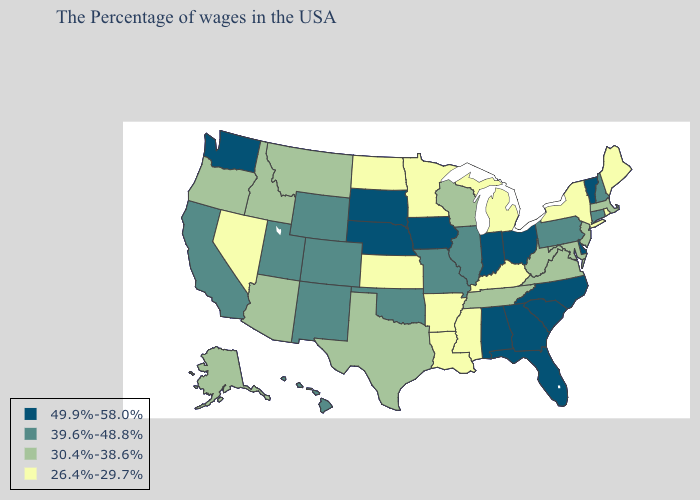What is the value of Texas?
Short answer required. 30.4%-38.6%. Name the states that have a value in the range 39.6%-48.8%?
Keep it brief. New Hampshire, Connecticut, Pennsylvania, Illinois, Missouri, Oklahoma, Wyoming, Colorado, New Mexico, Utah, California, Hawaii. What is the lowest value in states that border California?
Write a very short answer. 26.4%-29.7%. Name the states that have a value in the range 26.4%-29.7%?
Concise answer only. Maine, Rhode Island, New York, Michigan, Kentucky, Mississippi, Louisiana, Arkansas, Minnesota, Kansas, North Dakota, Nevada. Name the states that have a value in the range 26.4%-29.7%?
Write a very short answer. Maine, Rhode Island, New York, Michigan, Kentucky, Mississippi, Louisiana, Arkansas, Minnesota, Kansas, North Dakota, Nevada. Among the states that border New Mexico , does Texas have the lowest value?
Give a very brief answer. Yes. What is the value of Nevada?
Give a very brief answer. 26.4%-29.7%. Which states have the lowest value in the South?
Answer briefly. Kentucky, Mississippi, Louisiana, Arkansas. Does the first symbol in the legend represent the smallest category?
Concise answer only. No. Does Indiana have a lower value than Arizona?
Give a very brief answer. No. What is the lowest value in the USA?
Answer briefly. 26.4%-29.7%. What is the lowest value in the USA?
Write a very short answer. 26.4%-29.7%. Does South Carolina have the highest value in the South?
Quick response, please. Yes. Name the states that have a value in the range 39.6%-48.8%?
Short answer required. New Hampshire, Connecticut, Pennsylvania, Illinois, Missouri, Oklahoma, Wyoming, Colorado, New Mexico, Utah, California, Hawaii. Does the first symbol in the legend represent the smallest category?
Concise answer only. No. 